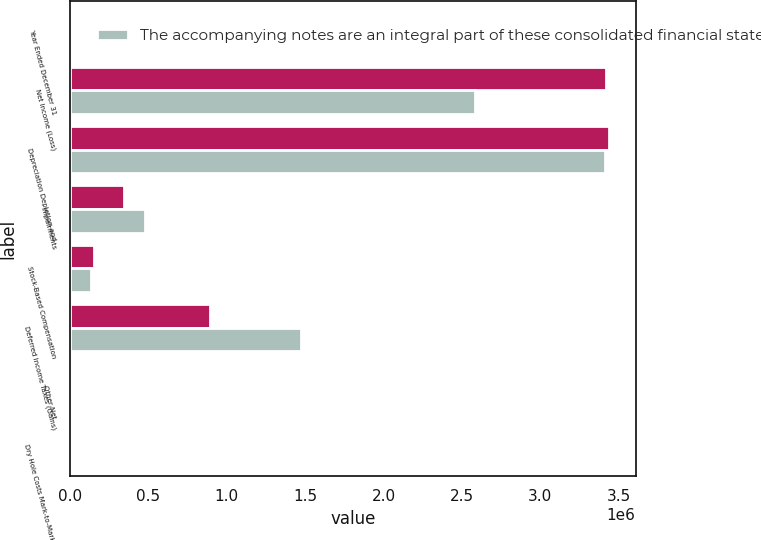Convert chart. <chart><loc_0><loc_0><loc_500><loc_500><stacked_bar_chart><ecel><fcel>Year Ended December 31<fcel>Net Income (Loss)<fcel>Depreciation Depletion and<fcel>Impairments<fcel>Stock-Based Compensation<fcel>Deferred Income Taxes (Gains)<fcel>Other Net<fcel>Dry Hole Costs Mark-to-Market<nl><fcel>nan<fcel>2018<fcel>3.41904e+06<fcel>3.43541e+06<fcel>347021<fcel>155337<fcel>894156<fcel>7066<fcel>5405<nl><fcel>The accompanying notes are an integral part of these consolidated financial statements.<fcel>2017<fcel>2.58258e+06<fcel>3.40939e+06<fcel>479240<fcel>133849<fcel>1.47387e+06<fcel>6546<fcel>4609<nl></chart> 